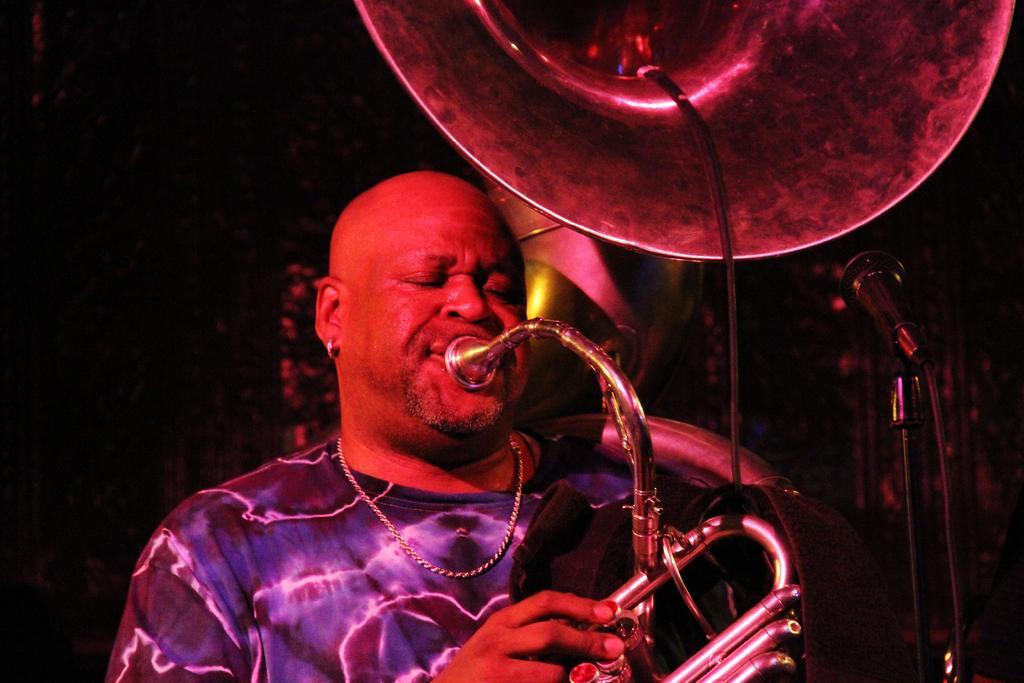How would you summarize this image in a sentence or two? In this image, There is a person wearing clothes. This person is holding and playing a musical instrument. There is a mic in the bottom right of the image. 